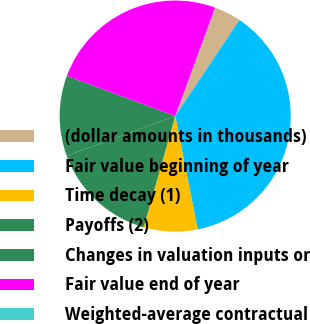Convert chart. <chart><loc_0><loc_0><loc_500><loc_500><pie_chart><fcel>(dollar amounts in thousands)<fcel>Fair value beginning of year<fcel>Time decay (1)<fcel>Payoffs (2)<fcel>Changes in valuation inputs or<fcel>Fair value end of year<fcel>Weighted-average contractual<nl><fcel>3.76%<fcel>37.51%<fcel>7.51%<fcel>15.01%<fcel>11.26%<fcel>24.96%<fcel>0.01%<nl></chart> 